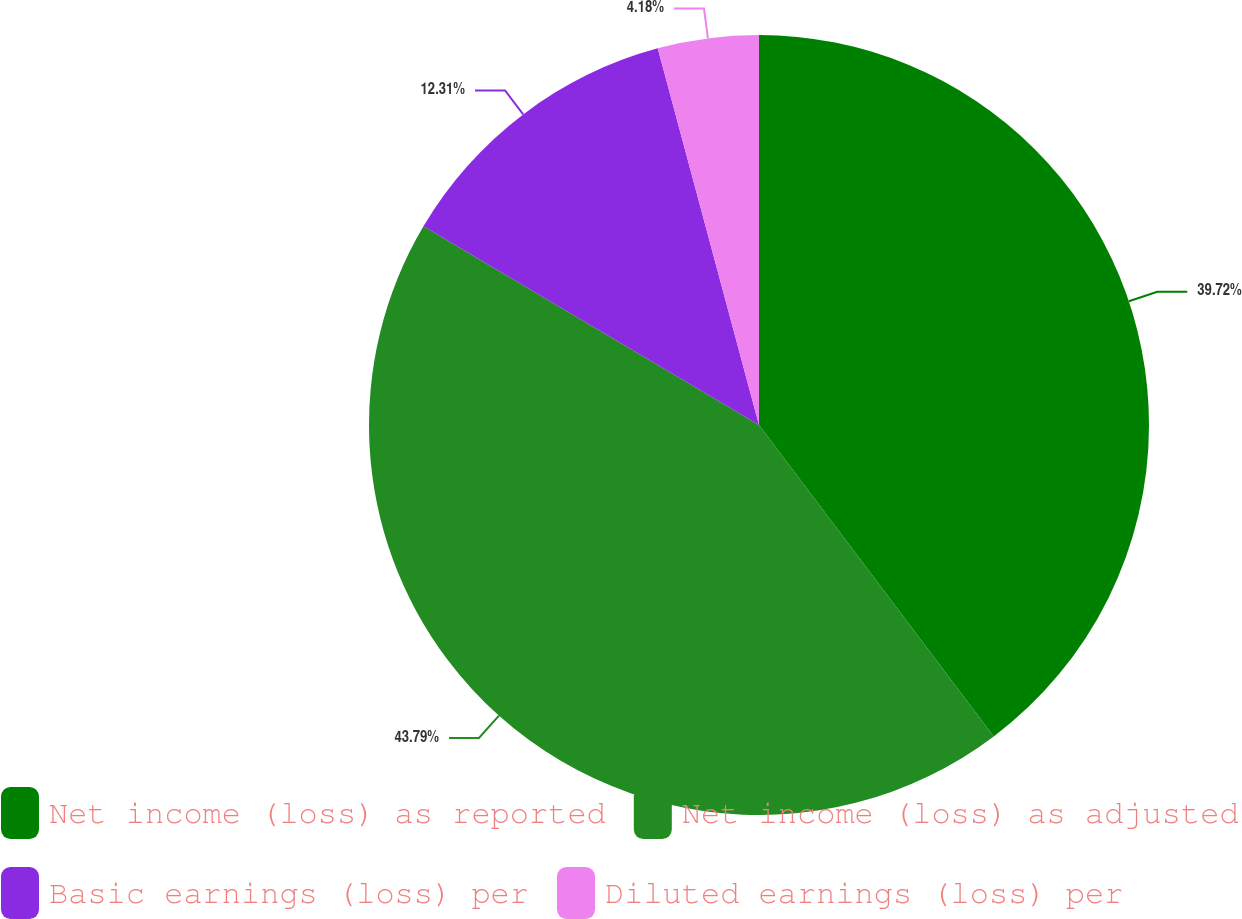<chart> <loc_0><loc_0><loc_500><loc_500><pie_chart><fcel>Net income (loss) as reported<fcel>Net income (loss) as adjusted<fcel>Basic earnings (loss) per<fcel>Diluted earnings (loss) per<nl><fcel>39.72%<fcel>43.79%<fcel>12.31%<fcel>4.18%<nl></chart> 